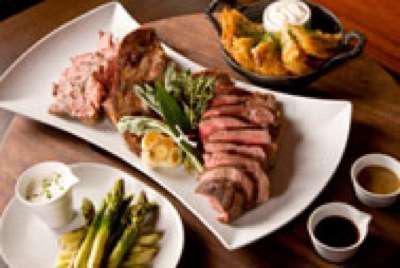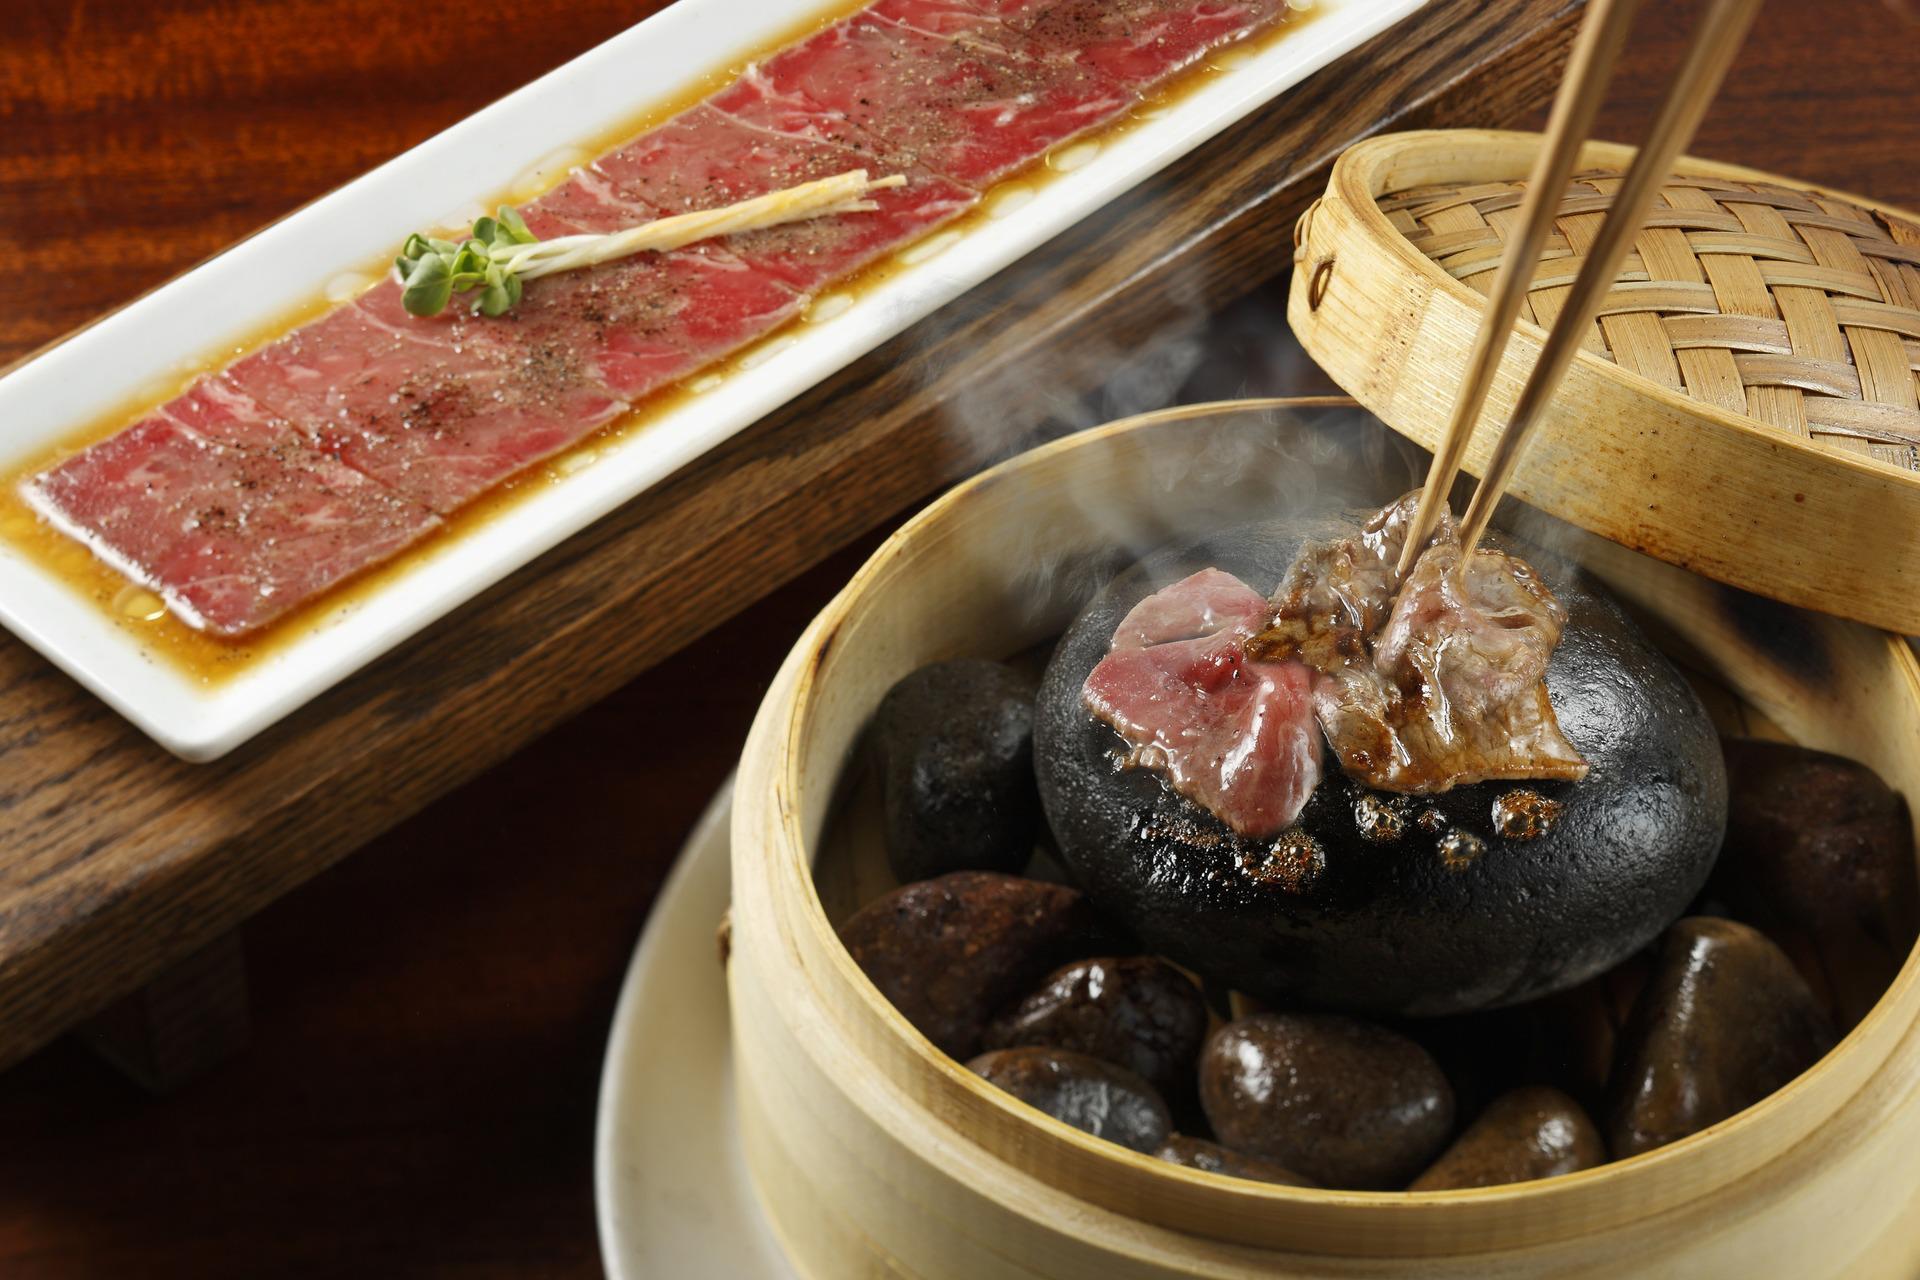The first image is the image on the left, the second image is the image on the right. Assess this claim about the two images: "there is sliced steak on a white oval plate, there is roasted garlic and greens on the plate and next to the plate is a silver teapot". Correct or not? Answer yes or no. No. The first image is the image on the left, the second image is the image on the right. Assess this claim about the two images: "In at least one image there is a bamboo bowl holding hot stones and topped with chopsticks.". Correct or not? Answer yes or no. Yes. 